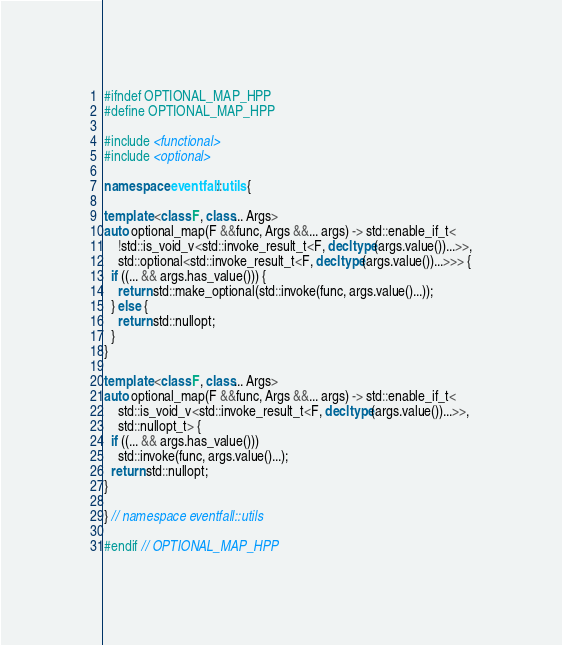<code> <loc_0><loc_0><loc_500><loc_500><_C++_>#ifndef OPTIONAL_MAP_HPP
#define OPTIONAL_MAP_HPP

#include <functional>
#include <optional>

namespace eventfall::utils {

template <class F, class... Args>
auto optional_map(F &&func, Args &&... args) -> std::enable_if_t<
    !std::is_void_v<std::invoke_result_t<F, decltype(args.value())...>>,
    std::optional<std::invoke_result_t<F, decltype(args.value())...>>> {
  if ((... && args.has_value())) {
    return std::make_optional(std::invoke(func, args.value()...));
  } else {
    return std::nullopt;
  }
}

template <class F, class... Args>
auto optional_map(F &&func, Args &&... args) -> std::enable_if_t<
    std::is_void_v<std::invoke_result_t<F, decltype(args.value())...>>,
    std::nullopt_t> {
  if ((... && args.has_value()))
    std::invoke(func, args.value()...);
  return std::nullopt;
}

} // namespace eventfall::utils

#endif // OPTIONAL_MAP_HPP
</code> 